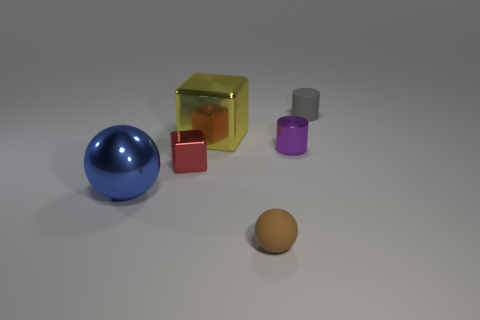Add 1 big gray shiny balls. How many objects exist? 7 Subtract all spheres. How many objects are left? 4 Subtract 0 brown cubes. How many objects are left? 6 Subtract all gray matte cylinders. Subtract all tiny shiny objects. How many objects are left? 3 Add 3 small shiny cylinders. How many small shiny cylinders are left? 4 Add 6 gray things. How many gray things exist? 7 